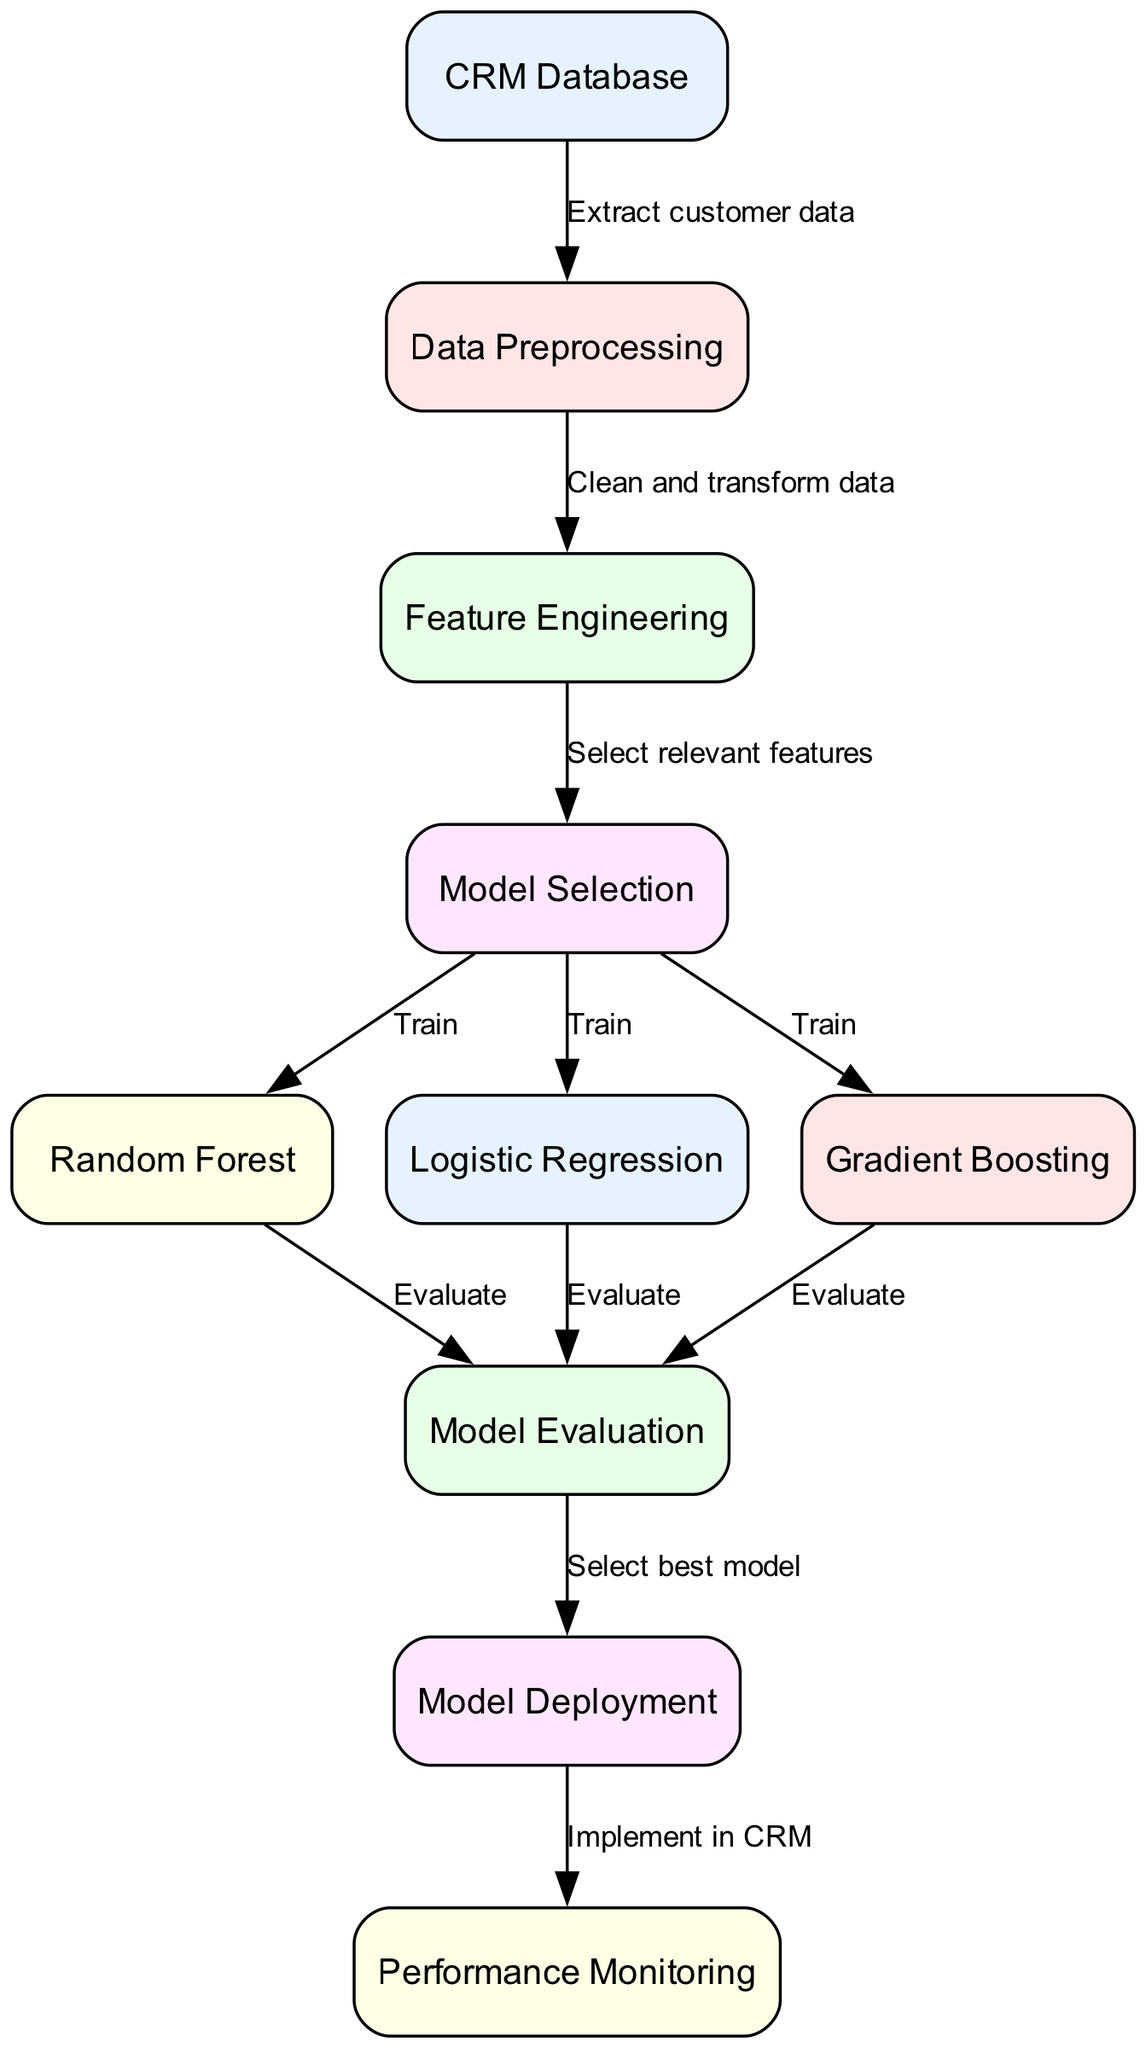What is the first step in the workflow? The diagram shows that the first step involves extracting data from the "CRM Database," which is the starting point of the workflow.
Answer: CRM Database How many models are trained in the model selection phase? The diagram lists three models: "Random Forest," "Logistic Regression," and "Gradient Boosting," indicating that three models are trained during this phase.
Answer: 3 What happens immediately after data preprocessing? According to the diagram, after "Data Preprocessing," the next step is "Feature Engineering," which indicates the flow of information from one process to the next.
Answer: Feature Engineering Which process is responsible for evaluating the trained models? The "Model Evaluation" node in the diagram is specifically connected to all three trained models, indicating that this process is responsible for evaluating the outcomes of those models.
Answer: Model Evaluation What is the last step before implementing the model in CRM? The diagram shows that after "Model Evaluation," the workflow proceeds to "Deployment," which is the step taken just before the model is implemented in the CRM environment.
Answer: Deployment How is model training indicated in this diagram? The diagram specifies the training process for each model through directed edges labeled "Train" that connect the "Model Selection" node to each of the three model nodes.
Answer: Train Which process follows the model deployment? According to the diagram, after the model is deployed, "Performance Monitoring" is the next step, indicating the continuing process of overseeing the deployed model's effectiveness.
Answer: Performance Monitoring What connects the "Feature Engineering" and "Model Selection" nodes? The edge labeled "Select relevant features" connects "Feature Engineering" to "Model Selection," indicating that the features selected during engineering are used for the selection of the model.
Answer: Select relevant features What is the main purpose of the "Data Preprocessing" node? The diagram notes that the purpose of "Data Preprocessing" is to clean and transform data, indicating its role in preparing raw data for further analysis.
Answer: Clean and transform data 